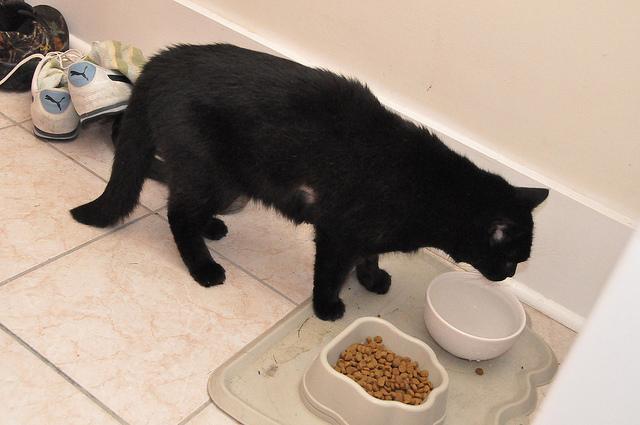Are the shoes in the background Pumas?
Answer briefly. Yes. What is the floor made of?
Be succinct. Tile. What is the cat looking at?
Short answer required. Water. Is the cat eating or drinking?
Write a very short answer. Drinking. 